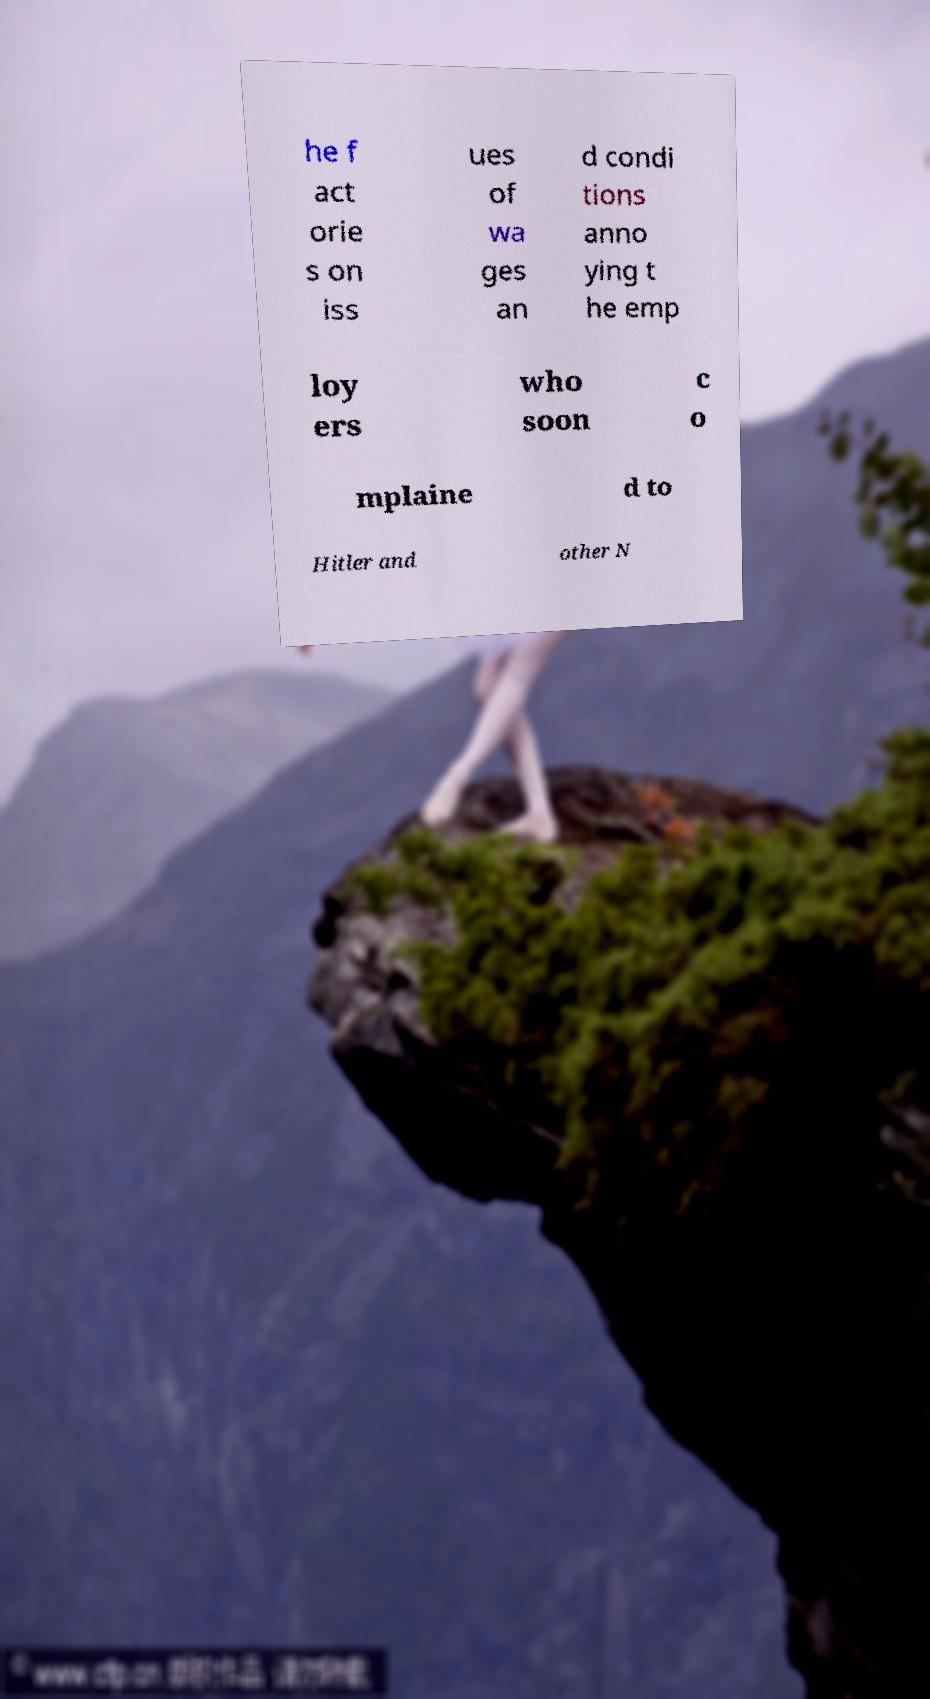There's text embedded in this image that I need extracted. Can you transcribe it verbatim? he f act orie s on iss ues of wa ges an d condi tions anno ying t he emp loy ers who soon c o mplaine d to Hitler and other N 